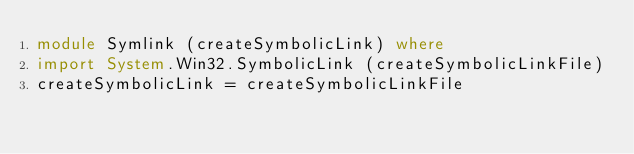Convert code to text. <code><loc_0><loc_0><loc_500><loc_500><_Haskell_>module Symlink (createSymbolicLink) where
import System.Win32.SymbolicLink (createSymbolicLinkFile)
createSymbolicLink = createSymbolicLinkFile
</code> 